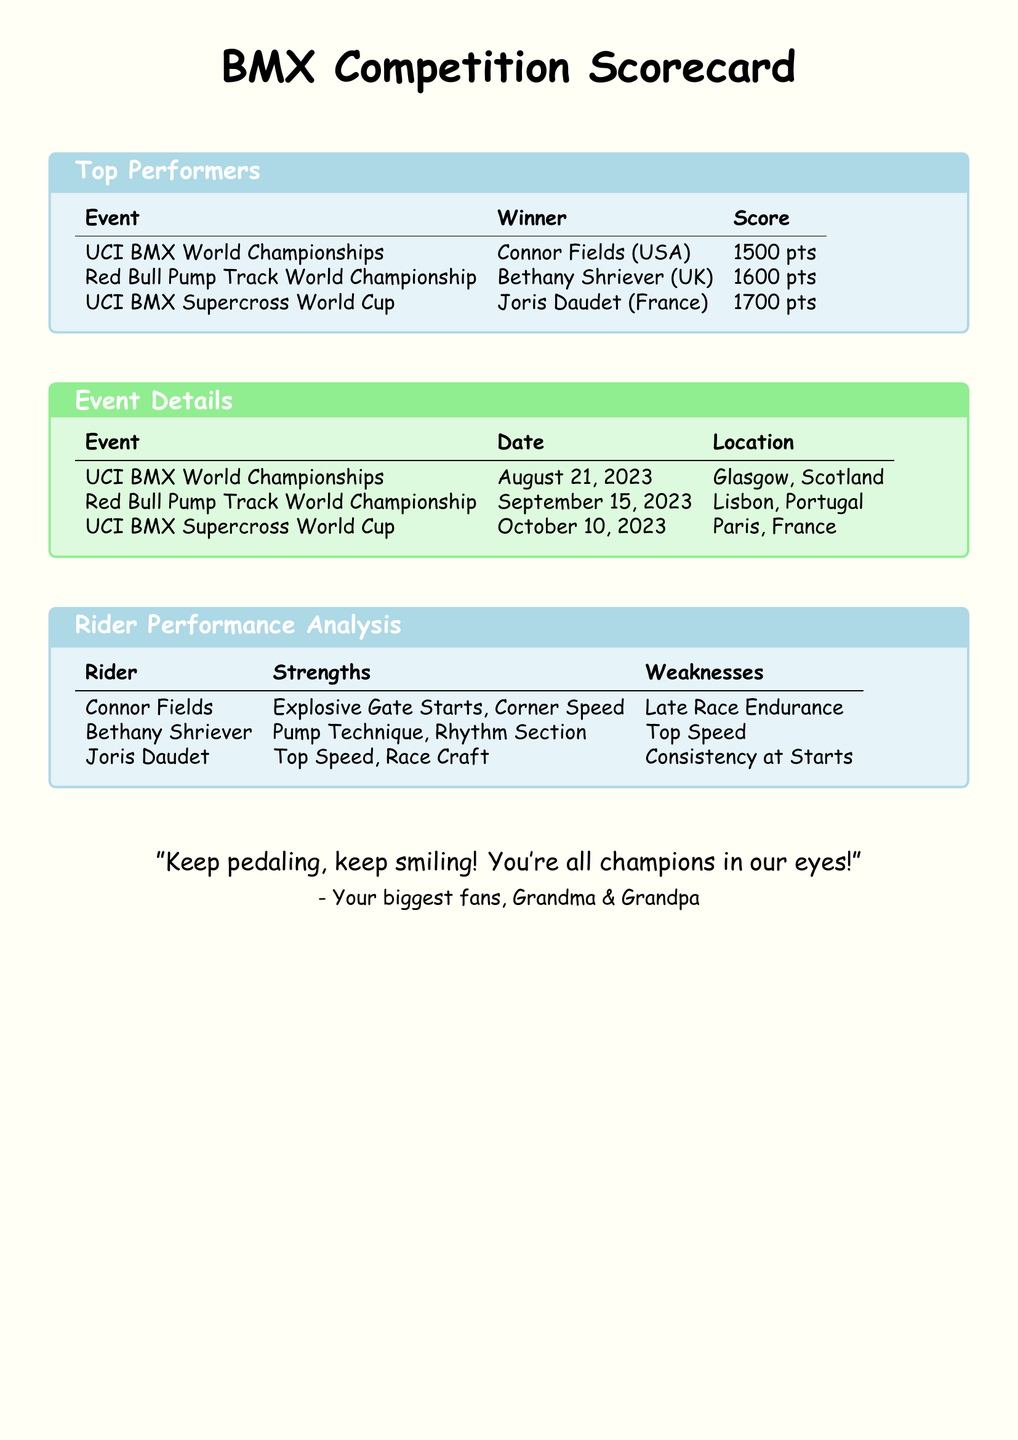what is the winner of the UCI BMX World Championships? The winner of the UCI BMX World Championships is listed in the Top Performers section as Connor Fields (USA).
Answer: Connor Fields (USA) how many points did Bethany Shriever earn? The score for Bethany Shriever is provided in the Top Performers section and indicates she earned 1600 points.
Answer: 1600 pts what date was the UCI BMX Supercross World Cup held? The date for the UCI BMX Supercross World Cup is mentioned in the Event Details section as October 10, 2023.
Answer: October 10, 2023 which rider has weaknesses in top speed? The Rider Performance Analysis indicates that Bethany Shriever has weaknesses in top speed.
Answer: Bethany Shriever where was the Red Bull Pump Track World Championship located? The Event Details section specifies that the Red Bull Pump Track World Championship took place in Lisbon, Portugal.
Answer: Lisbon, Portugal who is known for corner speed? The Rider Performance Analysis highlights Connor Fields as the rider known for corner speed.
Answer: Connor Fields what is Joris Daudet's strength? The document lists one of Joris Daudet's strengths in the Rider Performance Analysis as top speed.
Answer: Top Speed which event occurred first based on the document? The Event Details section outlines the UCI BMX World Championships as the first event listed by date.
Answer: UCI BMX World Championships 